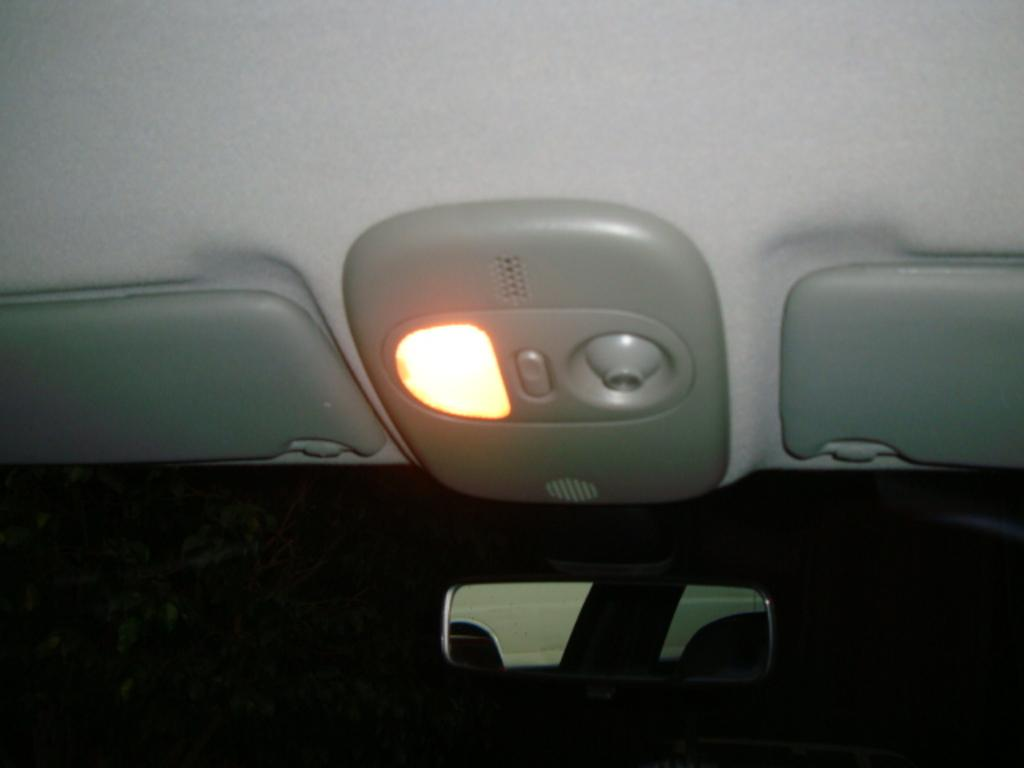What type of space is shown in the image? The image shows the interior of a car. What is one specific feature of the car's interior? There is a mirror in the car. What are the sun visors used for in the car? Sun visors are present in the car to block sunlight from the driver's eyes. Can you describe the lighting in the car? There is a light in the car. What other objects can be seen in the car? There are additional objects visible in the car. Reasoning: Let'g: Let's think step by step in order to produce the conversation. We start by identifying the main setting of the image, which is the interior of a car. Then, we describe specific features of the car's interior, such as the mirror and sun visors. We also mention the presence of a light and other objects in the car. Each question is designed to elicit a specific detail about the image that is known from the provided facts. Absurd Question/Answer: What type of rake is used to clean the car's interior in the image? There is no rake present in the image; it is a tool typically used for gardening and not for cleaning car interiors. What type of door is visible in the image? There is no door visible in the image, as it shows the interior of a car and not the exterior. --- Facts: 1. There is a person sitting on a bench in the image. 2. The person is reading a book. 3. The bench is located in a park. 4. There are trees in the background of the image. 5. The sky is visible in the image. Absurd Topics: fish, bicycle, fence Conversation: What is the person in the image doing? The person is sitting on a bench in the image. What activity is the person engaged in while sitting on the bench? The person is reading a book. Where is the bench located? The bench is located in a park. What can be seen in the background of the image? There are trees in the background of the image. What is visible at the top of the image? The sky is visible in the image. Reasoning: Let's think step by step in order to produce the conversation. We start by identifying the main subject in the image, which is the person sitting on the bench. Then, we expand the conversation to include the person's activity, which 